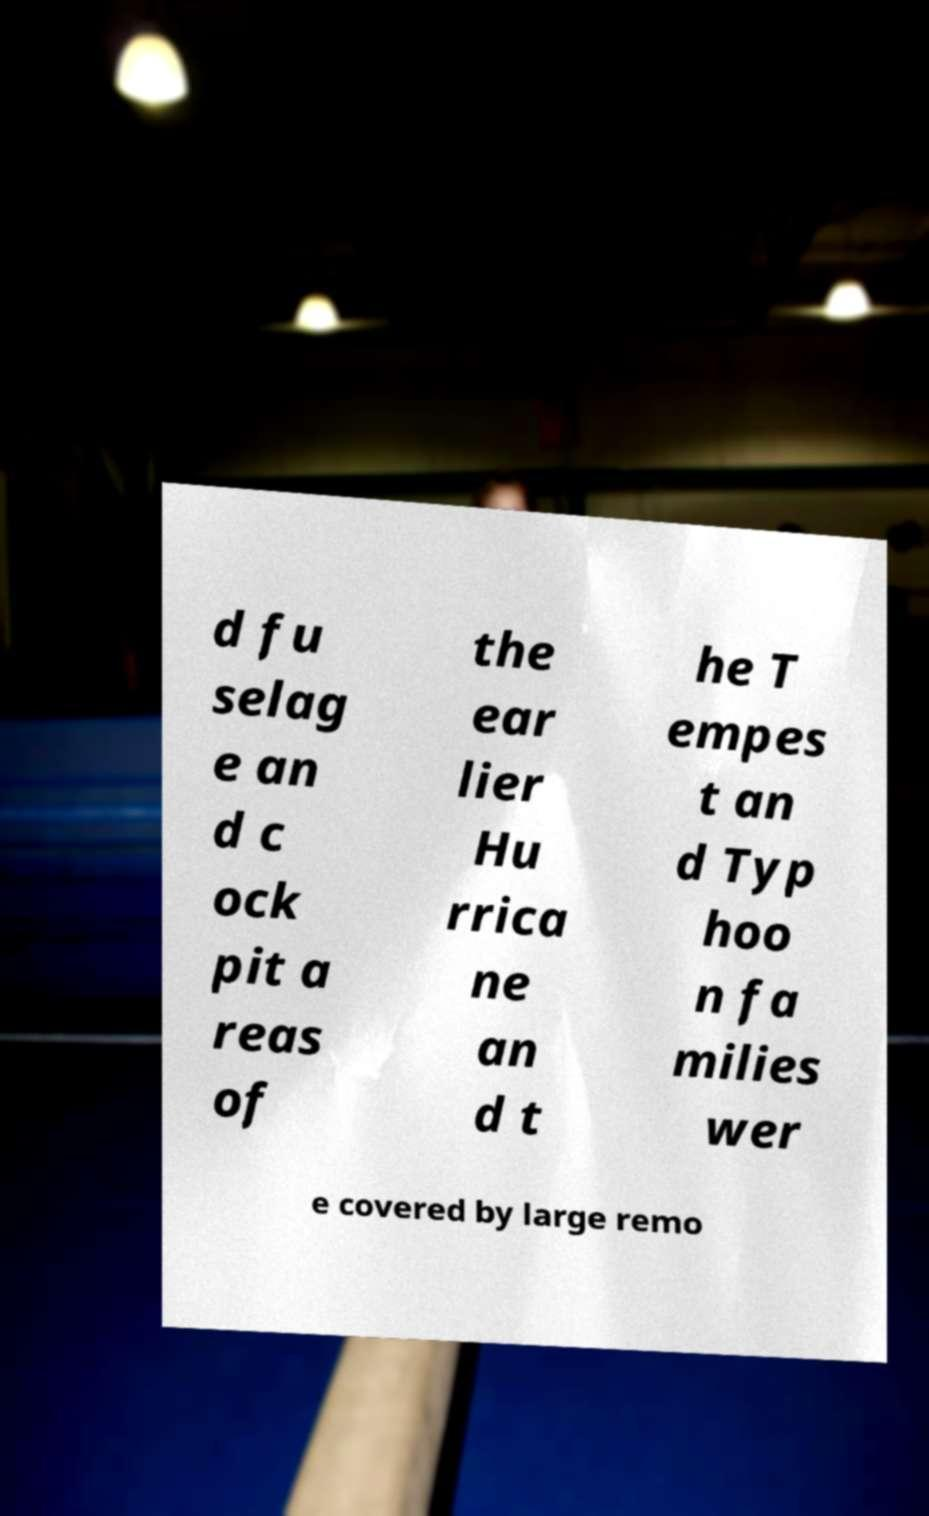Please read and relay the text visible in this image. What does it say? d fu selag e an d c ock pit a reas of the ear lier Hu rrica ne an d t he T empes t an d Typ hoo n fa milies wer e covered by large remo 